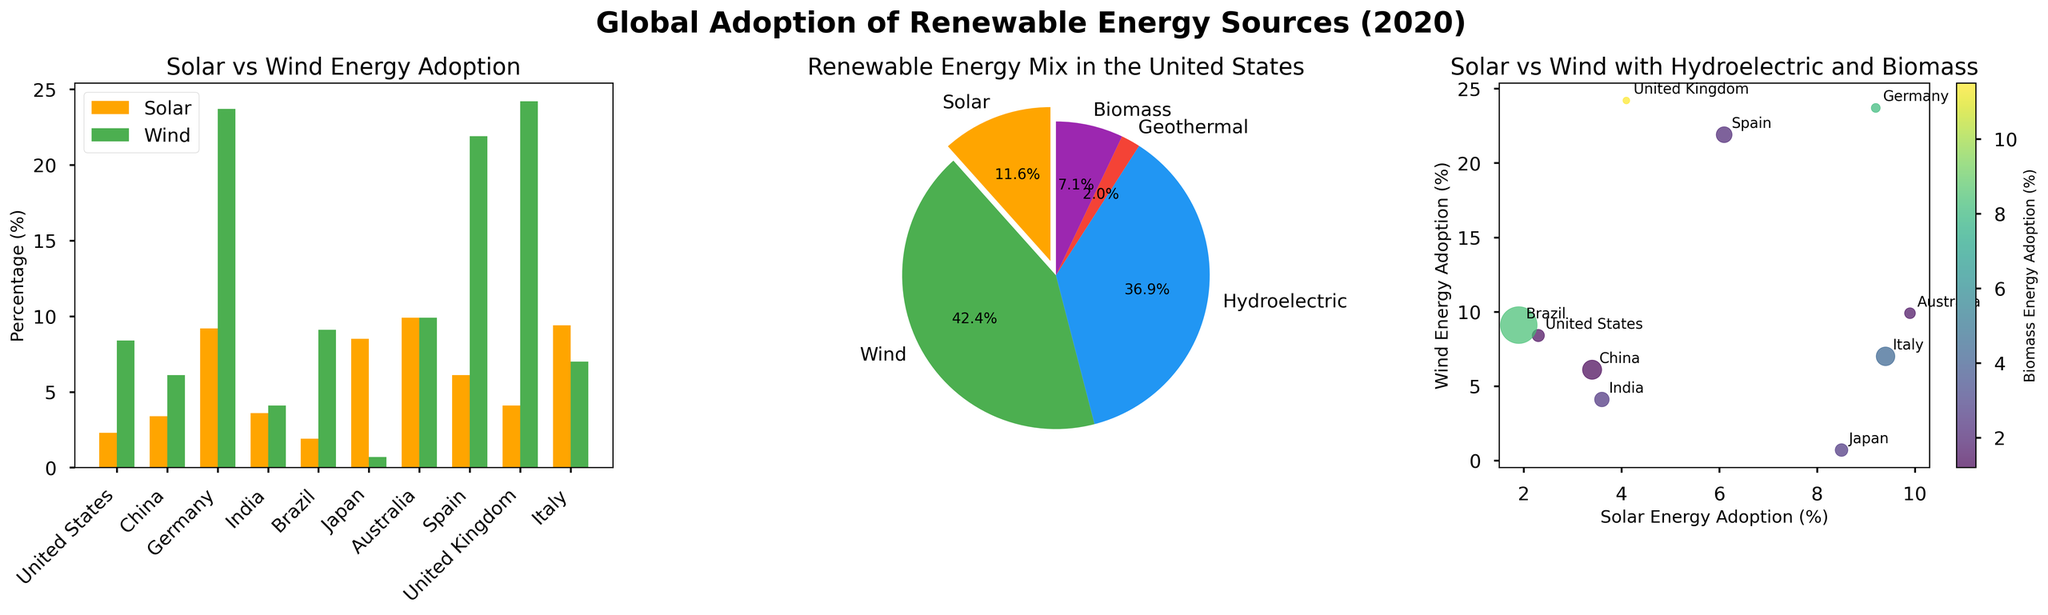What's the title of the figure? The title is written at the top of the figure for easy identification.
Answer: Global Adoption of Renewable Energy Sources (2020) Which countries have higher Solar Energy adoption rates than Wind Energy? By examining the bar plot, we compare the heights of the Solar columns to the Wind columns for each country. Only Australia, Japan, and Italy have higher Solar adoption rates than Wind adoption rates.
Answer: Australia, Japan, Italy What is the percentage of Wind energy in the United States? We take the Wind energy segment from the pie chart of the United States and observe the label indicating the percentage.
Answer: 8.4% Which country has the highest Hydroelectric energy adoption rate? By comparing the size of the Hydroelectric segments in the scatter plot, we see Brazil has the largest size, indicating the highest Hydroelectric energy adoption.
Answer: Brazil Compare the Biomass adoption rates between Spain and the United Kingdom. Which one is higher? Looking at the scatter plot, we observe the color shade representing Biomass adoption rates. The United Kingdom has a deeper color shade, indicating a higher Biomass adoption than Spain.
Answer: United Kingdom What’s the relationship between Solar and Wind energy adoption in Germany? In the scatter plot, Germany’s position shows a higher Wind adoption rate than Solar, and it's annotated nearby.
Answer: Wind > Solar How does Geothermal energy adoption compare across the countries in the bar plot? The bar plot doesn’t explicitly show Geothermal adoption rates, so we need to refer to the other subplots. The pie chart opportunity would specify for US only, hence inconclusive for all countries from these plots.
Answer: Not available in the bar plot What is the average adoption rate of Solar energy across all listed countries? Add the Solar energy adoption rates for each country and divide by the number of countries (9.9+8.5+9.4+9.2+6.1+4.1+3.6+3.4+2.3+1.9)/10 = 5.83%
Answer: 5.83% Which country’s scatterplot annotation is furthest on the Solar-Wind axis? By visually identifying the extreme points, Germany’s annotation rests at 9.2% Solar and 23.7% Wind, furthest along the axes in the scatter plot.
Answer: Germany 